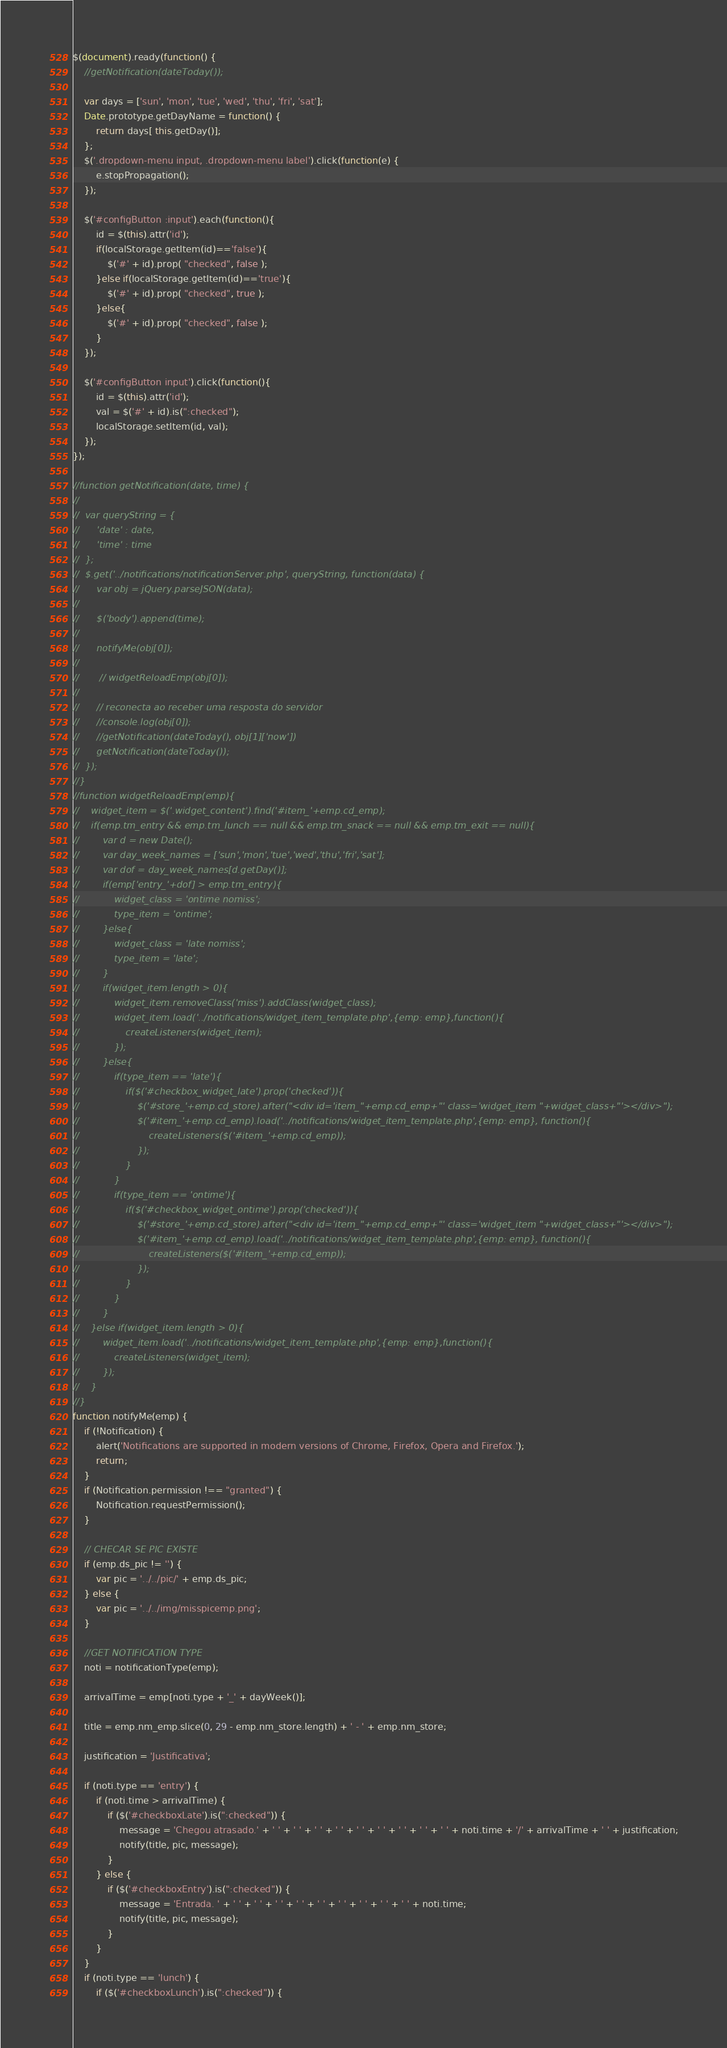Convert code to text. <code><loc_0><loc_0><loc_500><loc_500><_JavaScript_>$(document).ready(function() {
	//getNotification(dateToday());

	var days = ['sun', 'mon', 'tue', 'wed', 'thu', 'fri', 'sat'];
	Date.prototype.getDayName = function() {
		return days[ this.getDay()];
	};
	$('.dropdown-menu input, .dropdown-menu label').click(function(e) {
		e.stopPropagation();
	});
	
	$('#configButton :input').each(function(){
		id = $(this).attr('id');
		if(localStorage.getItem(id)=='false'){
			$('#' + id).prop( "checked", false );
		}else if(localStorage.getItem(id)=='true'){
			$('#' + id).prop( "checked", true );
		}else{
			$('#' + id).prop( "checked", false );
		}
	});

	$('#configButton input').click(function(){
		id = $(this).attr('id');
		val = $('#' + id).is(":checked");
		localStorage.setItem(id, val);
	});    
});

//function getNotification(date, time) {
//
//	var queryString = {
//		'date' : date,
//		'time' : time
//	};
//	$.get('../notifications/notificationServer.php', queryString, function(data) {
//		var obj = jQuery.parseJSON(data);
//
//		$('body').append(time);
//        
//		notifyMe(obj[0]);
//        
//       // widgetReloadEmp(obj[0]);
//        
//		// reconecta ao receber uma resposta do servidor
//		//console.log(obj[0]);
//	    //getNotification(dateToday(), obj[1]['now'])
//	    getNotification(dateToday());
//	});
//}
//function widgetReloadEmp(emp){
//    widget_item = $('.widget_content').find('#item_'+emp.cd_emp);
//    if(emp.tm_entry && emp.tm_lunch == null && emp.tm_snack == null && emp.tm_exit == null){
//        var d = new Date();
//        var day_week_names = ['sun','mon','tue','wed','thu','fri','sat'];
//        var dof = day_week_names[d.getDay()];
//        if(emp['entry_'+dof] > emp.tm_entry){
//            widget_class = 'ontime nomiss';
//            type_item = 'ontime';
//        }else{
//            widget_class = 'late nomiss';
//            type_item = 'late';
//        }
//        if(widget_item.length > 0){
//            widget_item.removeClass('miss').addClass(widget_class);
//            widget_item.load('../notifications/widget_item_template.php',{emp: emp},function(){
//                createListeners(widget_item);
//            });  
//        }else{
//            if(type_item == 'late'){
//                if($('#checkbox_widget_late').prop('checked')){
//                    $('#store_'+emp.cd_store).after("<div id='item_"+emp.cd_emp+"' class='widget_item "+widget_class+"'></div>");
//                    $('#item_'+emp.cd_emp).load('../notifications/widget_item_template.php',{emp: emp}, function(){
//                        createListeners($('#item_'+emp.cd_emp));
//                    });
//                }
//            }
//            if(type_item == 'ontime'){
//                if($('#checkbox_widget_ontime').prop('checked')){
//                    $('#store_'+emp.cd_store).after("<div id='item_"+emp.cd_emp+"' class='widget_item "+widget_class+"'></div>");
//                    $('#item_'+emp.cd_emp).load('../notifications/widget_item_template.php',{emp: emp}, function(){
//                        createListeners($('#item_'+emp.cd_emp));
//                    });
//                }
//            }
//        }
//    }else if(widget_item.length > 0){
//        widget_item.load('../notifications/widget_item_template.php',{emp: emp},function(){
//            createListeners(widget_item);
//        });  
//    }    
//}
function notifyMe(emp) {
	if (!Notification) {
		alert('Notifications are supported in modern versions of Chrome, Firefox, Opera and Firefox.');
		return;
	}
	if (Notification.permission !== "granted") {
		Notification.requestPermission();
	}

	// CHECAR SE PIC EXISTE
	if (emp.ds_pic != '') {
		var pic = '../../pic/' + emp.ds_pic;
	} else {
		var pic = '../../img/misspicemp.png';
	}

	//GET NOTIFICATION TYPE
	noti = notificationType(emp);

	arrivalTime = emp[noti.type + '_' + dayWeek()];

	title = emp.nm_emp.slice(0, 29 - emp.nm_store.length) + ' - ' + emp.nm_store;

	justification = 'Justificativa';

	if (noti.type == 'entry') {
		if (noti.time > arrivalTime) {
			if ($('#checkboxLate').is(":checked")) {
				message = 'Chegou atrasado.' + ' ' + ' ' + ' ' + ' ' + ' ' + ' ' + ' ' + ' ' + ' ' + noti.time + '/' + arrivalTime + ' ' + justification;
				notify(title, pic, message);
			}
		} else {
			if ($('#checkboxEntry').is(":checked")) {
				message = 'Entrada. ' + ' ' + ' ' + ' ' + ' ' + ' ' + ' ' + ' ' + ' ' + ' ' + noti.time;
				notify(title, pic, message);
			}
		}
	}
	if (noti.type == 'lunch') {
		if ($('#checkboxLunch').is(":checked")) {</code> 